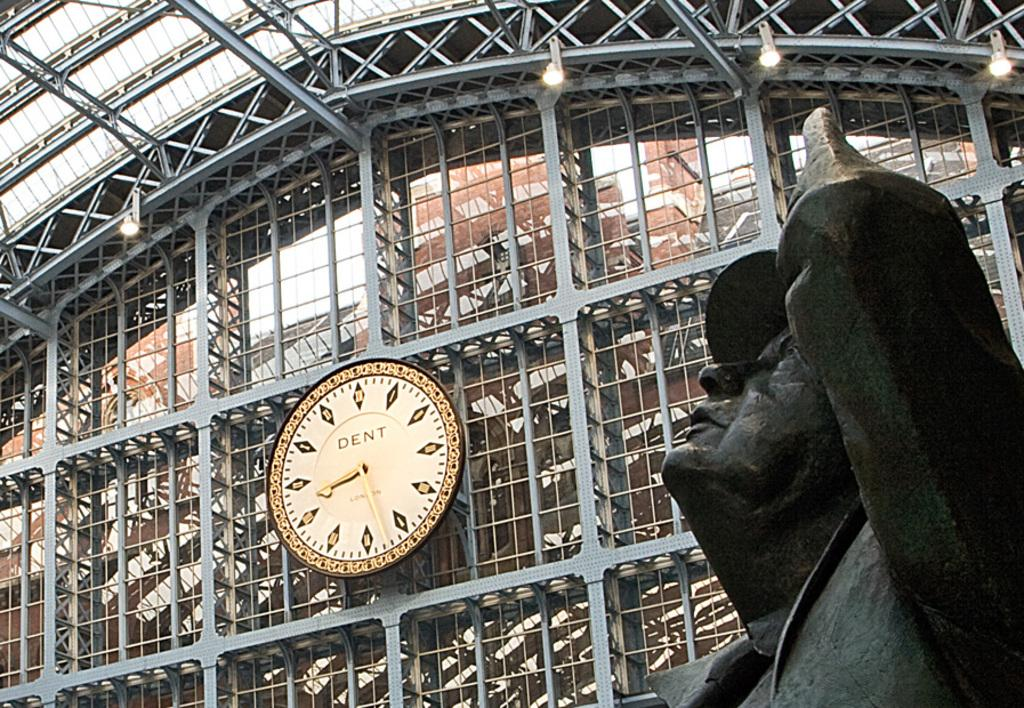<image>
Provide a brief description of the given image. a clock reads Dent is on a train station building 